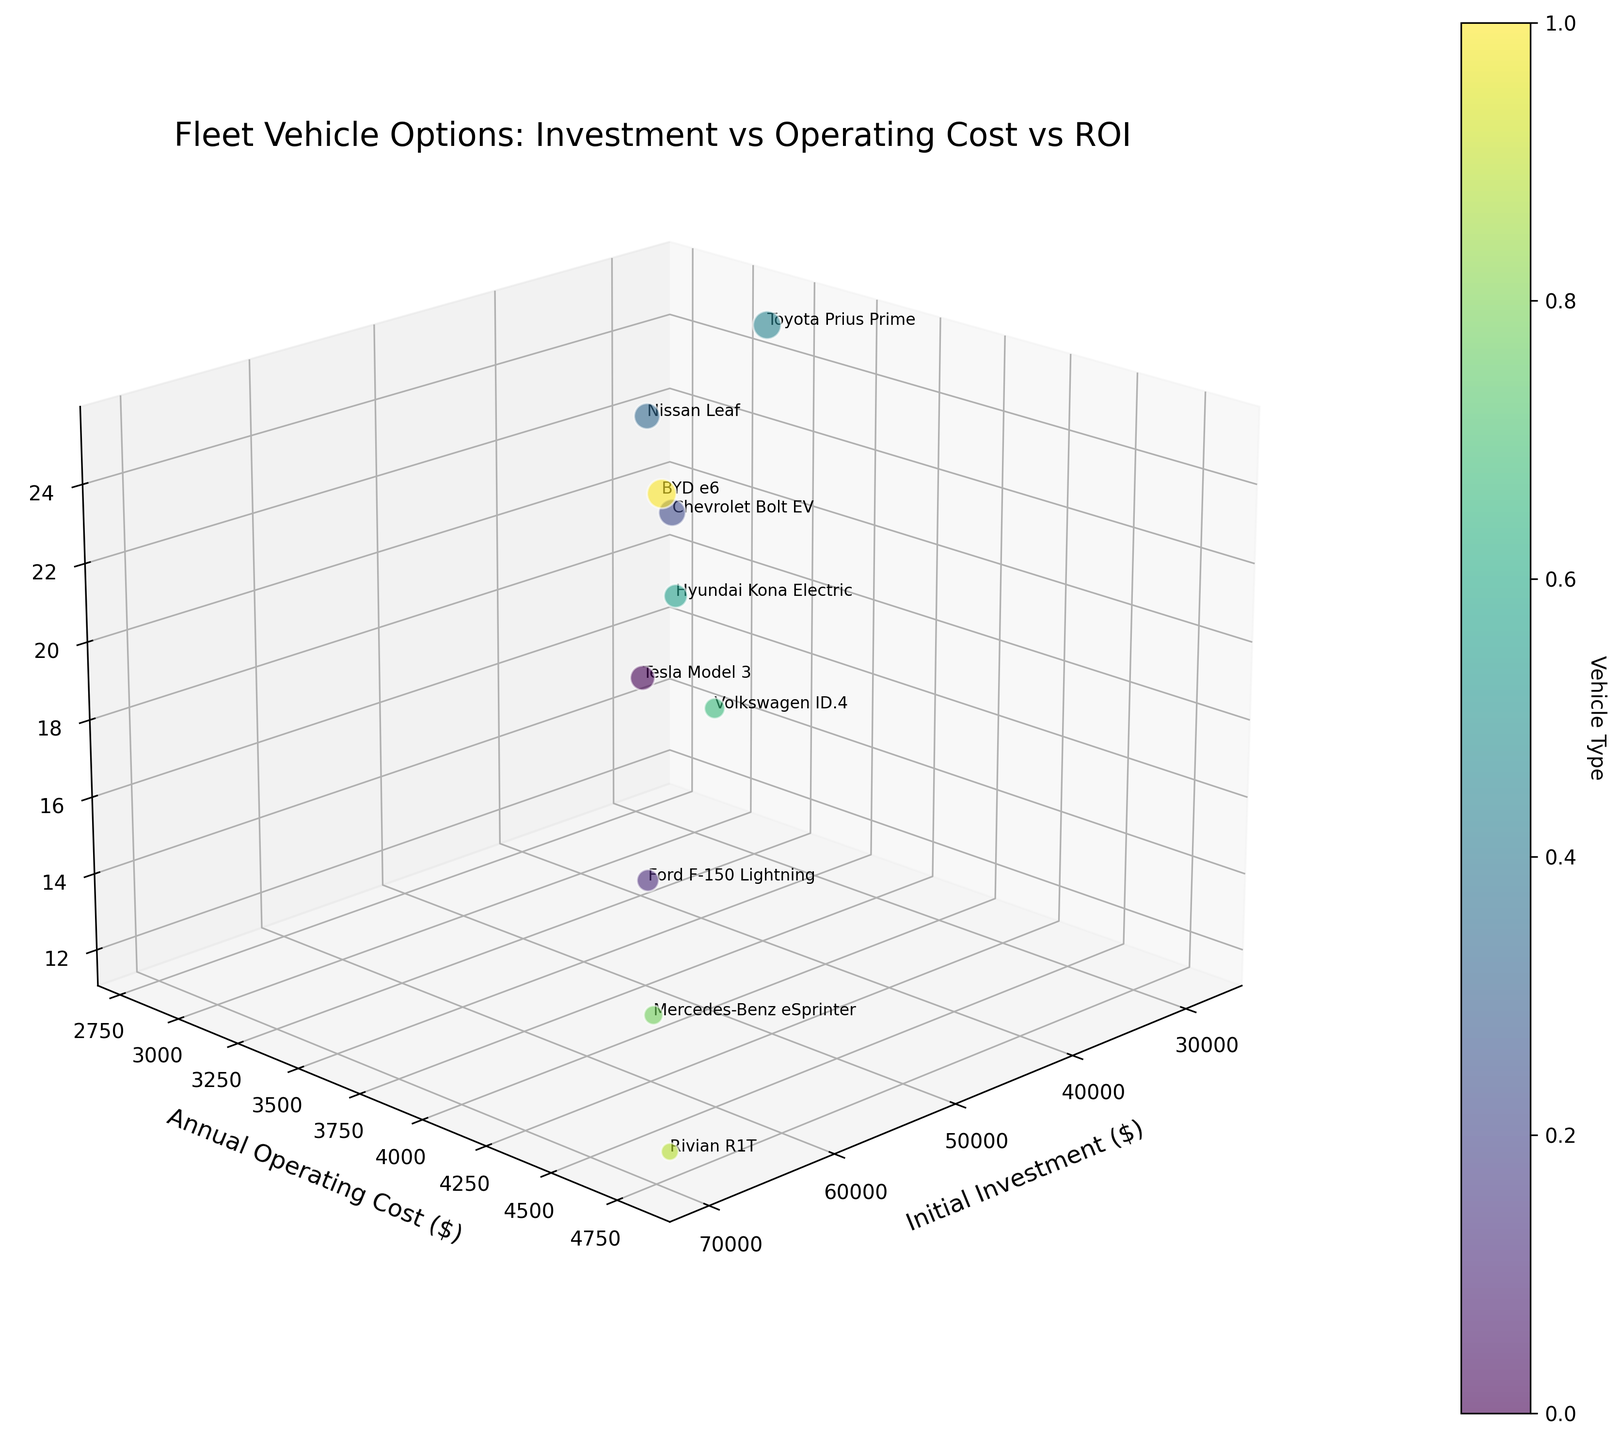What is the title of the figure? The title of the figure is typically displayed prominently at the top of the chart.
Answer: Fleet Vehicle Options: Investment vs Operating Cost vs ROI How many different vehicle types are represented in the figure? To answer this, count the number of unique vehicle types labeled in the chart.
Answer: 10 Which vehicle has the highest initial investment? By looking along the Initial Investment ($) axis and identifying the highest data point, we can determine the vehicle with the highest value.
Answer: Rivian R1T What is the range of ROI (%) across all vehicle types? Identify the minimum and maximum ROI values from the ROI axis and subtract the minimum from the maximum.
Answer: 13% Which vehicle has the smallest annual operating cost? Locate the lowest data point along the Annual Operating Cost ($) axis.
Answer: Nissan Leaf How many vehicle types have an ROI greater than 20%? Count all the data points where the z-value (ROI) is greater than 20%.
Answer: 3 Which vehicle has the largest fleet size? The bubble sizes correspond to fleet size; identify the largest bubble in the plot.
Answer: BYD e6 Can you identify a vehicle with an initial investment between $30,000 and $40,000 and an annual operating cost between $3,000 and $4,000? Find a data point within the specified ranges on the Initial Investment and Annual Operating Cost axes.
Answer: Hyundai Kona Electric How does the ROI of the Toyota Prius Prime compare to the Chevrolet Bolt EV? Locate both data points and compare their z-values (ROI).
Answer: Higher What is the average initial investment for the vehicles that have an ROI of at least 20%? Identify the vehicles with ROI ≥ 20%, sum their initial investments, and divide by the number of such vehicles.
Answer: $31666.67 How is the fleet size represented in the plot? Examine the visual cues used to denote fleet size, such as bubble size.
Answer: By bubble size 